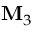Convert formula to latex. <formula><loc_0><loc_0><loc_500><loc_500>{ { M } _ { 3 } }</formula> 